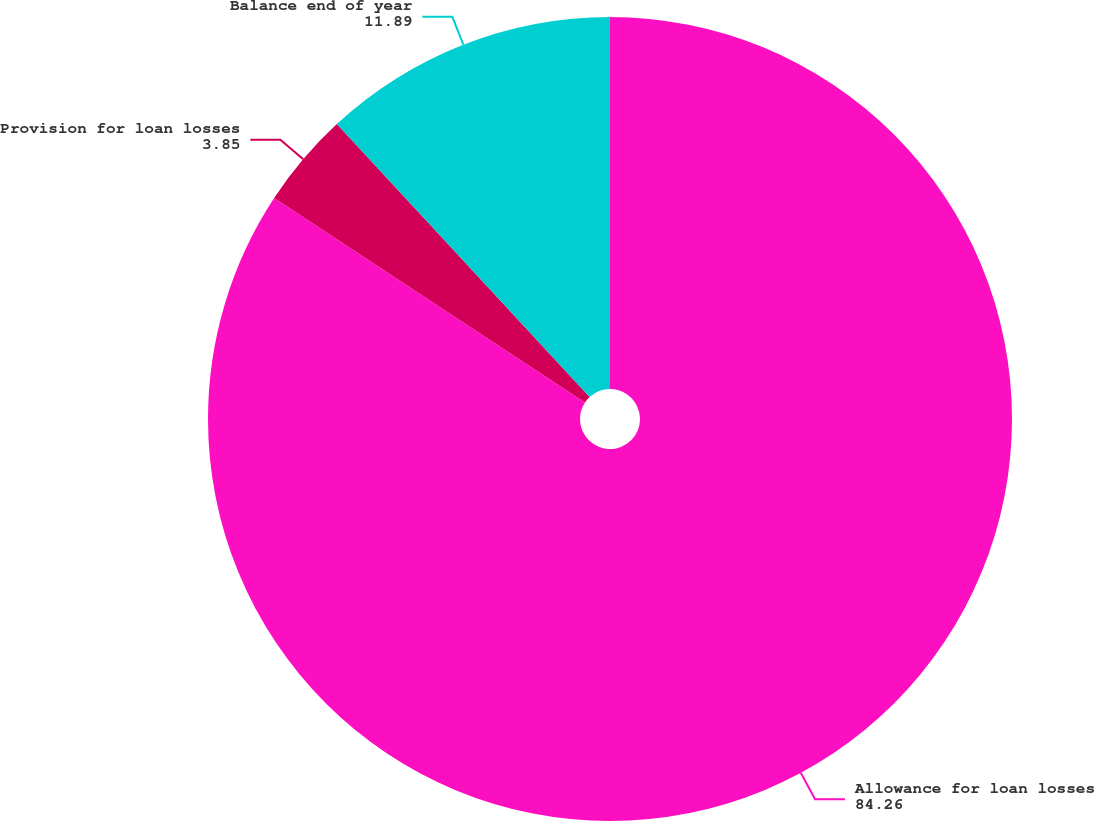Convert chart. <chart><loc_0><loc_0><loc_500><loc_500><pie_chart><fcel>Allowance for loan losses<fcel>Provision for loan losses<fcel>Balance end of year<nl><fcel>84.26%<fcel>3.85%<fcel>11.89%<nl></chart> 